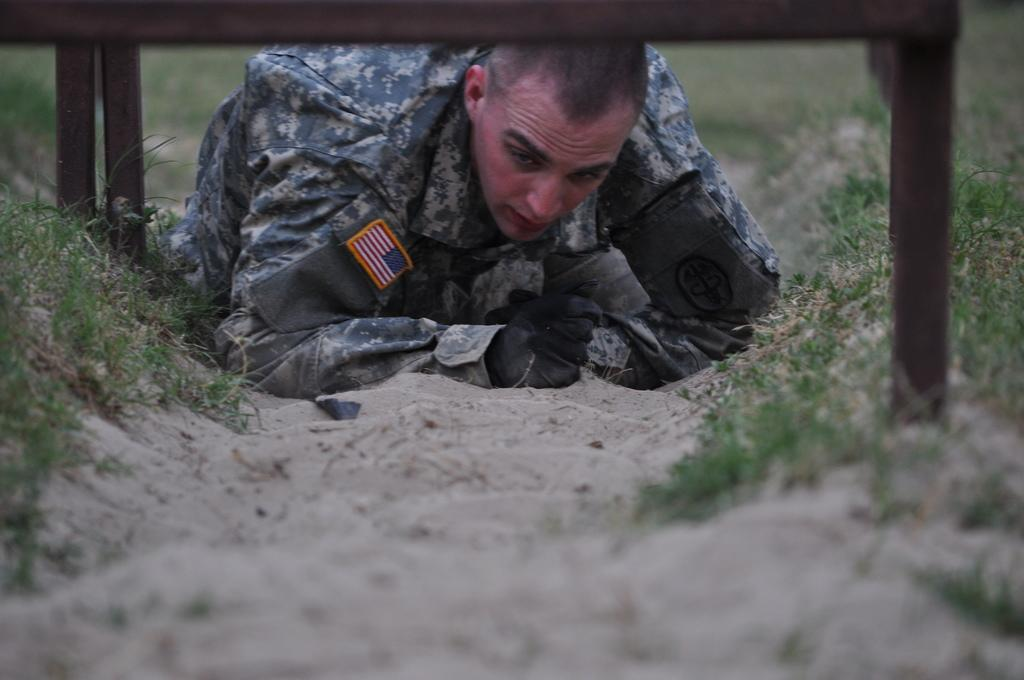What is the main subject of the image? There is a person on the ground in the image. What objects can be seen near the person? There are rods visible in the image. What type of terrain is present in the image? There is grass in the image. How would you describe the background of the image? The background of the image is blurry. What type of glove is the person wearing in the image? There is no glove visible in the image; the person's hands are not shown. 